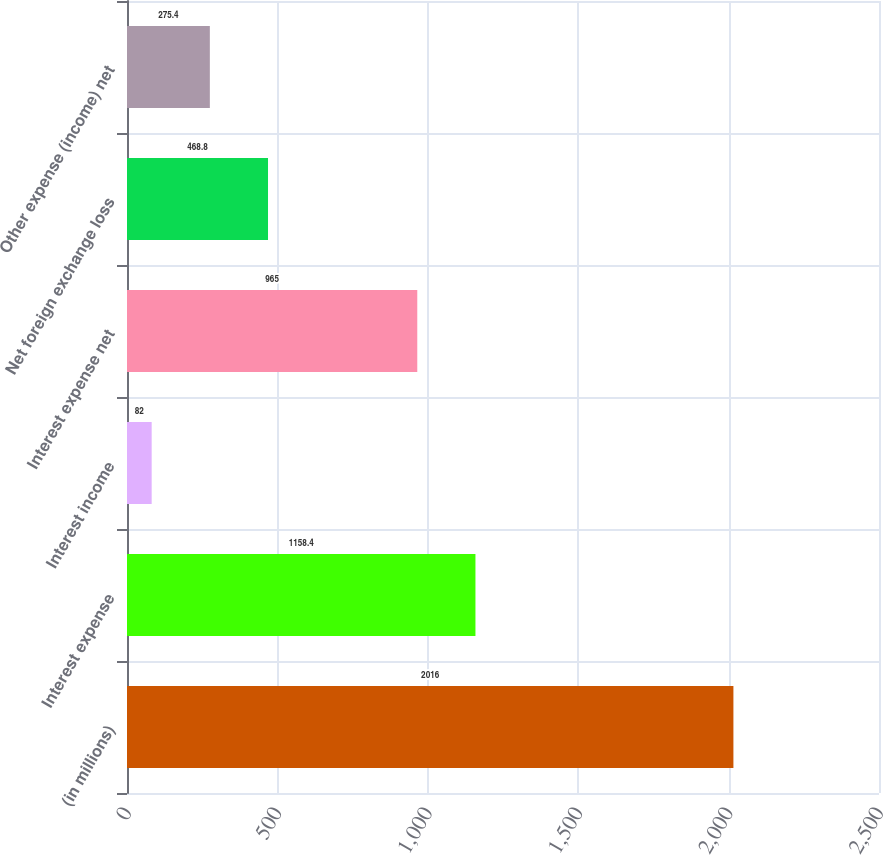<chart> <loc_0><loc_0><loc_500><loc_500><bar_chart><fcel>(in millions)<fcel>Interest expense<fcel>Interest income<fcel>Interest expense net<fcel>Net foreign exchange loss<fcel>Other expense (income) net<nl><fcel>2016<fcel>1158.4<fcel>82<fcel>965<fcel>468.8<fcel>275.4<nl></chart> 